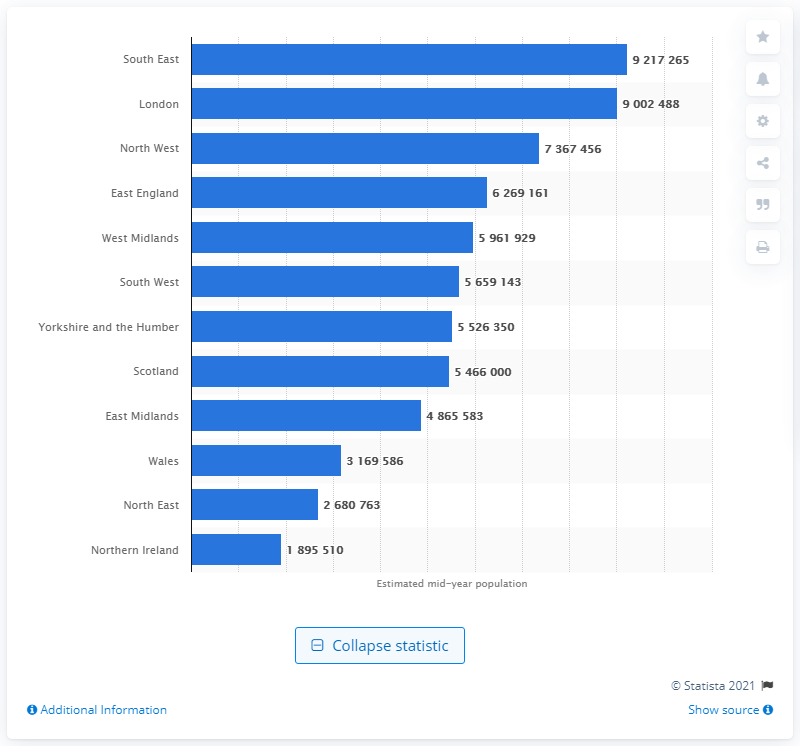List a handful of essential elements in this visual. In the United Kingdom, approximately 9.2 million people live in the city of London. In 2020, the population of South East England was approximately 9,217,265. 